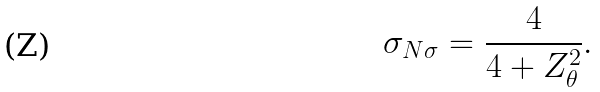<formula> <loc_0><loc_0><loc_500><loc_500>\sigma _ { N \sigma } = \frac { 4 } { 4 + Z _ { \theta } ^ { 2 } } .</formula> 